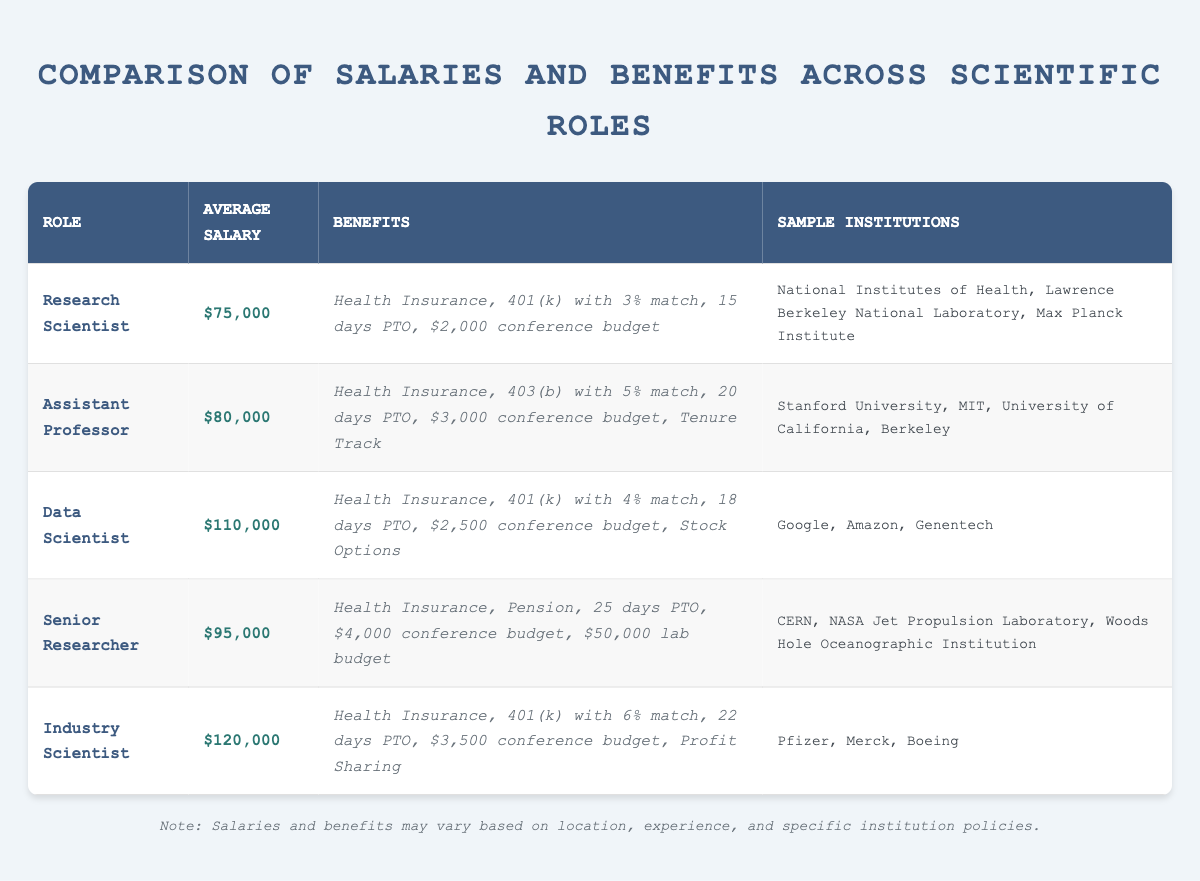What is the average salary of an Assistant Professor? The table shows that the average salary for the Assistant Professor role is listed as $80,000. This information can be found directly in the table under the 'Average Salary' column for the Assistant Professor row.
Answer: $80,000 How many days of paid time off does a Data Scientist receive? According to the table, the Data Scientist role has 18 days of paid time off indicated in the 'Benefits' column. This value corresponds directly to that specific role in the table.
Answer: 18 days Which scientific role has the highest average salary? The table indicates that the Industry Scientist has the highest average salary of $120,000 listed under its 'Average Salary' column, compared to other scientific roles in the table.
Answer: Industry Scientist What is the total conference budget for a Senior Researcher over 3 years? The conference budget for a Senior Researcher is $4,000 per year. Multiplying this by 3 years gives a total of $4,000 * 3 = $12,000. This information comes directly from the 'Benefits' column for the Senior Researcher role in the table.
Answer: $12,000 Do all scientific roles listed offer health insurance? Yes, the table reveals that all listed roles, including Research Scientist, Assistant Professor, Data Scientist, Senior Researcher, and Industry Scientist, have a 'Health Insurance' benefit indicated as true in the 'Benefits' column.
Answer: Yes What is the difference in average salary between Research Scientist and Data Scientist? The average salary for Research Scientist is $75,000 while that for Data Scientist is $110,000. The difference is calculated as $110,000 - $75,000 = $35,000. This requires comparing the two average salary values from the respective rows in the table.
Answer: $35,000 How many institutions are listed for an Assistant Professor? The table shows that the Assistant Professor role is associated with 3 institutions: Stanford University, MIT, and University of California, Berkeley. This count can be obtained by reviewing the 'Sample Institutions' column for the Assistant Professor role.
Answer: 3 What retirement plan does an Industry Scientist have? The table specifies that the Industry Scientist has a retirement plan of '401(k) with 6% match' under the 'Benefits' column. This information is directly pulled from the respective row of the table.
Answer: 401(k) with 6% match Is tenure track available for the role of Research Scientist? No, the table does not list 'Tenure Track' as a benefit for the Research Scientist role, which indicates that it is not available for that position. This is validated by checking the 'Benefits' column for the Research Scientist row.
Answer: No 